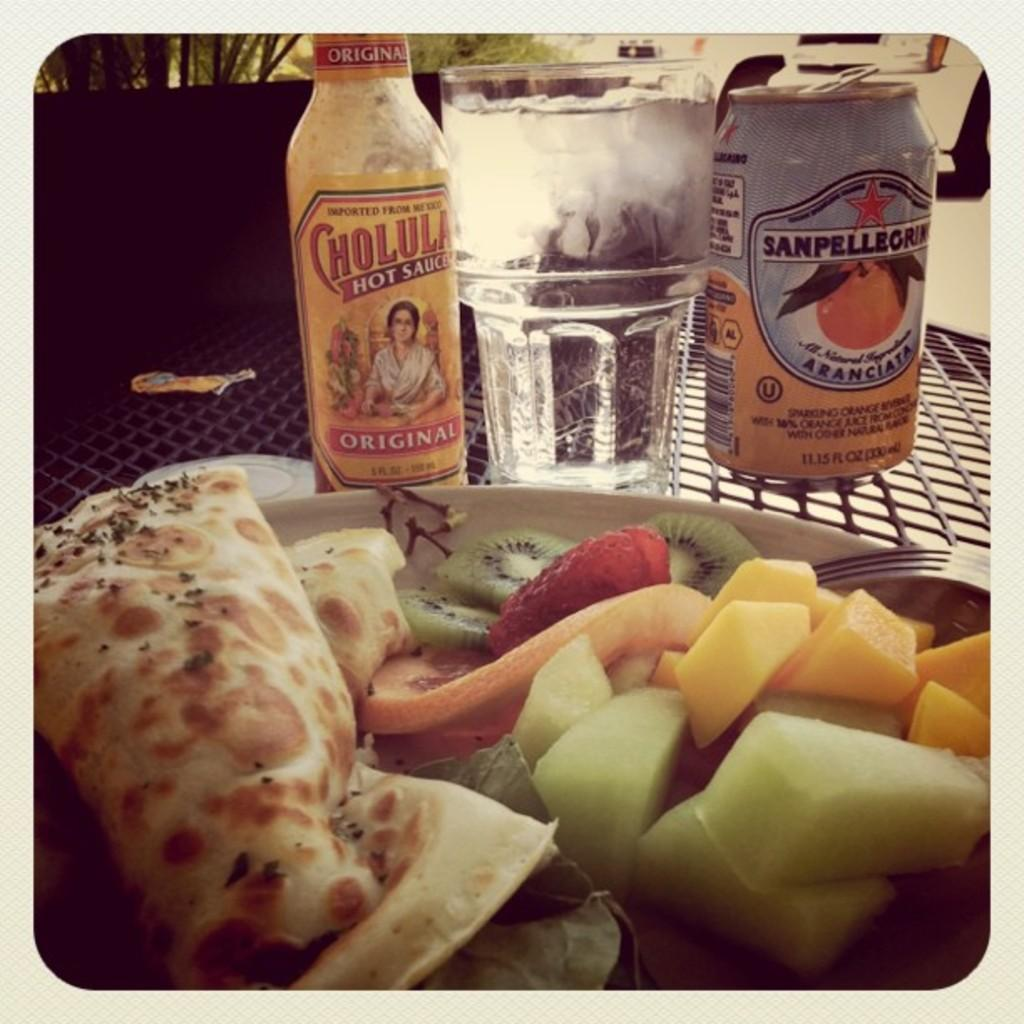What is the main object in the image? There is a table in the image. What can be seen on the table? There are items placed on the table. What can be seen in the background of the image? There are plants in the background of the image. What type of noise can be heard coming from the sack in the image? There is no sack present in the image, so it is not possible to determine what, if any, noise might be heard. 